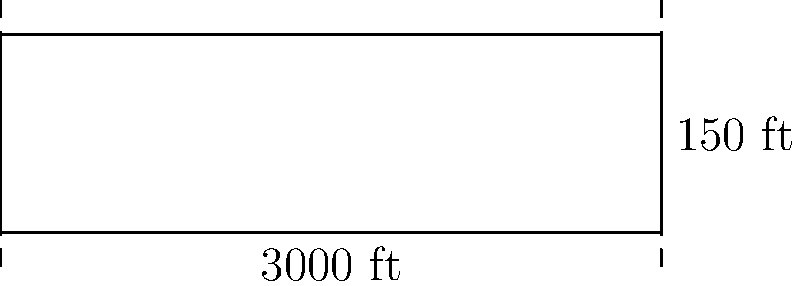As a frequent flyer, you've become curious about airport infrastructure. Delta Airlines is planning to resurface one of its main runways at Hartsfield-Jackson Atlanta International Airport. The rectangular runway measures 3000 feet in length and 150 feet in width. What is the perimeter of this runway? Let's approach this step-by-step:

1) The runway is rectangular, so we need to use the formula for the perimeter of a rectangle.

2) The formula for the perimeter of a rectangle is:
   $$P = 2l + 2w$$
   where $P$ is the perimeter, $l$ is the length, and $w$ is the width.

3) We are given:
   Length $(l) = 3000$ feet
   Width $(w) = 150$ feet

4) Let's substitute these values into our formula:
   $$P = 2(3000) + 2(150)$$

5) Now, let's calculate:
   $$P = 6000 + 300 = 6300$$

Therefore, the perimeter of the runway is 6300 feet.
Answer: 6300 feet 